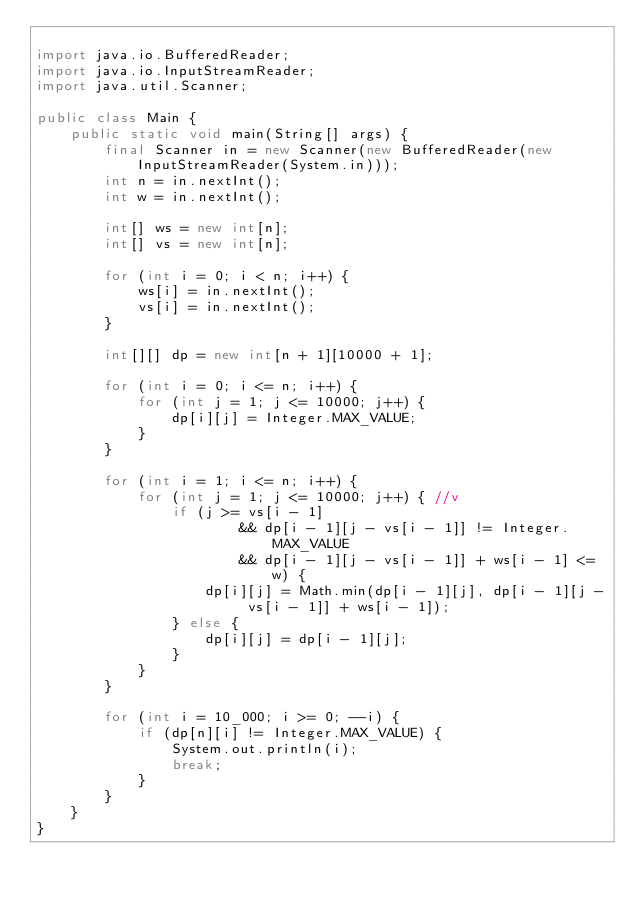Convert code to text. <code><loc_0><loc_0><loc_500><loc_500><_Java_>
import java.io.BufferedReader;
import java.io.InputStreamReader;
import java.util.Scanner;

public class Main {
    public static void main(String[] args) {
        final Scanner in = new Scanner(new BufferedReader(new InputStreamReader(System.in)));
        int n = in.nextInt();
        int w = in.nextInt();

        int[] ws = new int[n];
        int[] vs = new int[n];

        for (int i = 0; i < n; i++) {
            ws[i] = in.nextInt();
            vs[i] = in.nextInt();
        }

        int[][] dp = new int[n + 1][10000 + 1];

        for (int i = 0; i <= n; i++) {
            for (int j = 1; j <= 10000; j++) {
                dp[i][j] = Integer.MAX_VALUE;
            }
        }

        for (int i = 1; i <= n; i++) {
            for (int j = 1; j <= 10000; j++) { //v
                if (j >= vs[i - 1]
                        && dp[i - 1][j - vs[i - 1]] != Integer.MAX_VALUE
                        && dp[i - 1][j - vs[i - 1]] + ws[i - 1] <= w) {
                    dp[i][j] = Math.min(dp[i - 1][j], dp[i - 1][j - vs[i - 1]] + ws[i - 1]);
                } else {
                    dp[i][j] = dp[i - 1][j];
                }
            }
        }

        for (int i = 10_000; i >= 0; --i) {
            if (dp[n][i] != Integer.MAX_VALUE) {
                System.out.println(i);
                break;
            }
        }
    }
}
</code> 